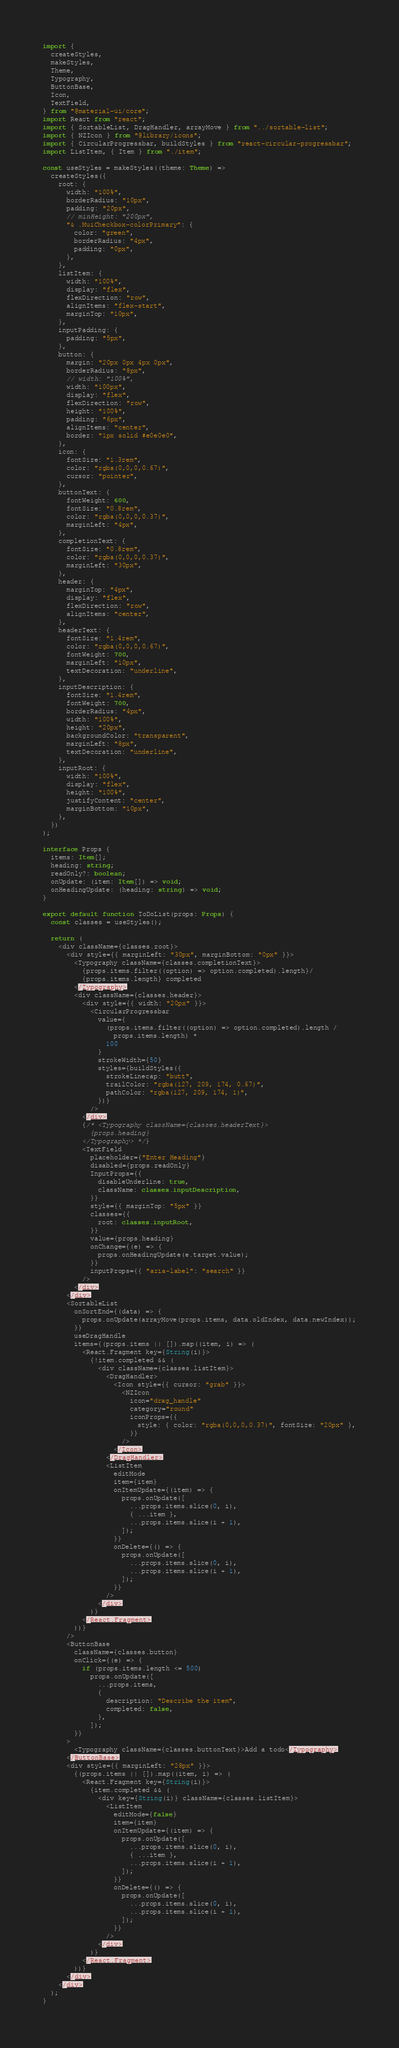Convert code to text. <code><loc_0><loc_0><loc_500><loc_500><_TypeScript_>import {
  createStyles,
  makeStyles,
  Theme,
  Typography,
  ButtonBase,
  Icon,
  TextField,
} from "@material-ui/core";
import React from "react";
import { SortableList, DragHandler, arrayMove } from "../sortable-list";
import { NZIcon } from "@library/icons";
import { CircularProgressbar, buildStyles } from "react-circular-progressbar";
import ListItem, { Item } from "./item";

const useStyles = makeStyles((theme: Theme) =>
  createStyles({
    root: {
      width: "100%",
      borderRadius: "10px",
      padding: "20px",
      // minHeight: "200px",
      "& .MuiCheckbox-colorPrimary": {
        color: "green",
        borderRadius: "4px",
        padding: "0px",
      },
    },
    listItem: {
      width: "100%",
      display: "flex",
      flexDirection: "row",
      alignItems: "flex-start",
      marginTop: "10px",
    },
    inputPadding: {
      padding: "5px",
    },
    button: {
      margin: "20px 0px 4px 0px",
      borderRadius: "8px",
      // width: "100%",
      width: "100px",
      display: "flex",
      flexDirection: "row",
      height: "100%",
      padding: "6px",
      alignItems: "center",
      border: "1px solid #e0e0e0",
    },
    icon: {
      fontSize: "1.3rem",
      color: "rgba(0,0,0,0.67)",
      cursor: "pointer",
    },
    buttonText: {
      fontWeight: 600,
      fontSize: "0.8rem",
      color: "rgba(0,0,0,0.37)",
      marginLeft: "4px",
    },
    completionText: {
      fontSize: "0.8rem",
      color: "rgba(0,0,0,0.37)",
      marginLeft: "30px",
    },
    header: {
      marginTop: "4px",
      display: "flex",
      flexDirection: "row",
      alignItems: "center",
    },
    headerText: {
      fontSize: "1.4rem",
      color: "rgba(0,0,0,0.67)",
      fontWeight: 700,
      marginLeft: "10px",
      textDecoration: "underline",
    },
    inputDescription: {
      fontSize: "1.4rem",
      fontWeight: 700,
      borderRadius: "4px",
      width: "100%",
      height: "20px",
      backgroundColor: "transparent",
      marginLeft: "8px",
      textDecoration: "underline",
    },
    inputRoot: {
      width: "100%",
      display: "flex",
      height: "100%",
      justifyContent: "center",
      marginBottom: "10px",
    },
  })
);

interface Props {
  items: Item[];
  heading: string;
  readOnly?: boolean;
  onUpdate: (item: Item[]) => void;
  onHeadingUpdate: (heading: string) => void;
}

export default function ToDoList(props: Props) {
  const classes = useStyles();

  return (
    <div className={classes.root}>
      <div style={{ marginLeft: "30px", marginBottom: "0px" }}>
        <Typography className={classes.completionText}>
          {props.items.filter((option) => option.completed).length}/
          {props.items.length} completed
        </Typography>
        <div className={classes.header}>
          <div style={{ width: "20px" }}>
            <CircularProgressbar
              value={
                (props.items.filter((option) => option.completed).length /
                  props.items.length) *
                100
              }
              strokeWidth={50}
              styles={buildStyles({
                strokeLinecap: "butt",
                trailColor: "rgba(127, 209, 174, 0.67)",
                pathColor: "rgba(127, 209, 174, 1)",
              })}
            />
          </div>
          {/* <Typography className={classes.headerText}>
            {props.heading}
          </Typography> */}
          <TextField
            placeholder={"Enter Heading"}
            disabled={props.readOnly}
            InputProps={{
              disableUnderline: true,
              className: classes.inputDescription,
            }}
            style={{ marginTop: "5px" }}
            classes={{
              root: classes.inputRoot,
            }}
            value={props.heading}
            onChange={(e) => {
              props.onHeadingUpdate(e.target.value);
            }}
            inputProps={{ "aria-label": "search" }}
          />
        </div>
      </div>
      <SortableList
        onSortEnd={(data) => {
          props.onUpdate(arrayMove(props.items, data.oldIndex, data.newIndex));
        }}
        useDragHandle
        items={(props.items || []).map((item, i) => (
          <React.Fragment key={String(i)}>
            {!item.completed && (
              <div className={classes.listItem}>
                <DragHandler>
                  <Icon style={{ cursor: "grab" }}>
                    <NZIcon
                      icon="drag_handle"
                      category="round"
                      iconProps={{
                        style: { color: "rgba(0,0,0,0.37)", fontSize: "20px" },
                      }}
                    />
                  </Icon>
                </DragHandler>
                <ListItem
                  editMode
                  item={item}
                  onItemUpdate={(item) => {
                    props.onUpdate([
                      ...props.items.slice(0, i),
                      { ...item },
                      ...props.items.slice(i + 1),
                    ]);
                  }}
                  onDelete={() => {
                    props.onUpdate([
                      ...props.items.slice(0, i),
                      ...props.items.slice(i + 1),
                    ]);
                  }}
                />
              </div>
            )}
          </React.Fragment>
        ))}
      />
      <ButtonBase
        className={classes.button}
        onClick={(e) => {
          if (props.items.length <= 500)
            props.onUpdate([
              ...props.items,
              {
                description: "Describe the item",
                completed: false,
              },
            ]);
        }}
      >
        <Typography className={classes.buttonText}>Add a todo</Typography>
      </ButtonBase>
      <div style={{ marginLeft: "28px" }}>
        {(props.items || []).map((item, i) => (
          <React.Fragment key={String(i)}>
            {item.completed && (
              <div key={String(i)} className={classes.listItem}>
                <ListItem
                  editMode={false}
                  item={item}
                  onItemUpdate={(item) => {
                    props.onUpdate([
                      ...props.items.slice(0, i),
                      { ...item },
                      ...props.items.slice(i + 1),
                    ]);
                  }}
                  onDelete={() => {
                    props.onUpdate([
                      ...props.items.slice(0, i),
                      ...props.items.slice(i + 1),
                    ]);
                  }}
                />
              </div>
            )}
          </React.Fragment>
        ))}
      </div>
    </div>
  );
}
</code> 